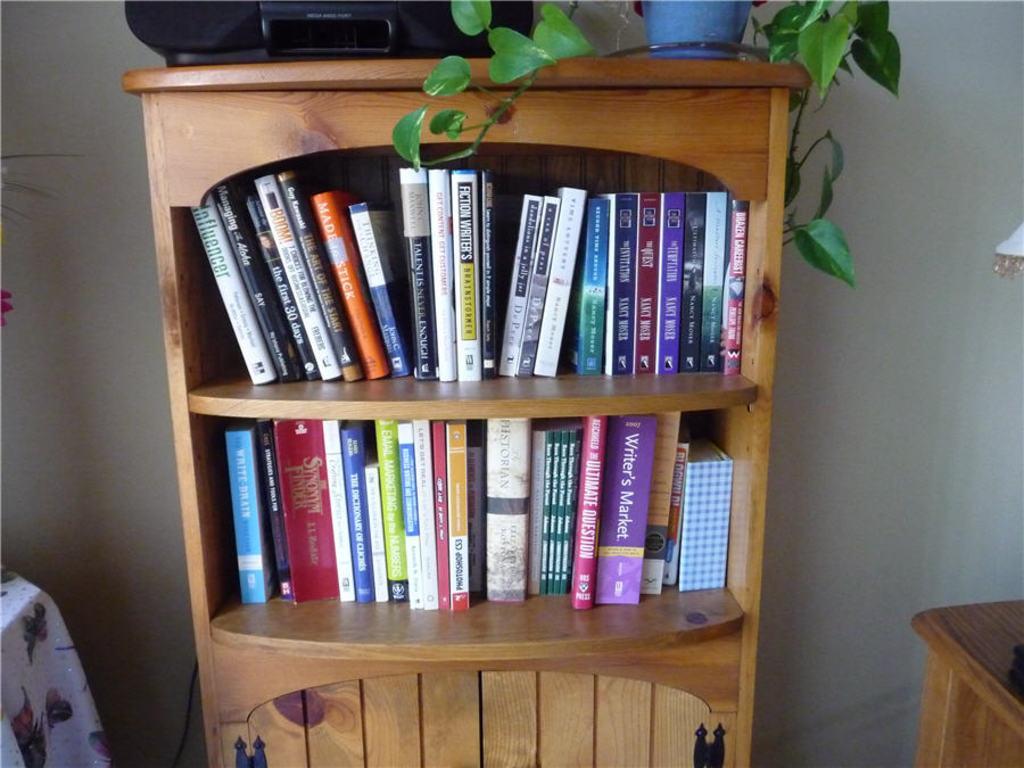How would you summarize this image in a sentence or two? In the middle of this image, there are books arranged on the shelves of a cupboard. There are a potted plant and a radio arranged on the top of this cupboard. On the left side, there is an object covered with white color cloth. On the right side, there is a wooden object. In the background, there is a white wall. 